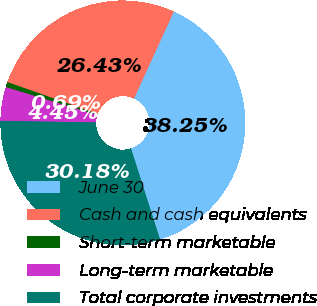Convert chart. <chart><loc_0><loc_0><loc_500><loc_500><pie_chart><fcel>June 30<fcel>Cash and cash equivalents<fcel>Short-term marketable<fcel>Long-term marketable<fcel>Total corporate investments<nl><fcel>38.25%<fcel>26.43%<fcel>0.69%<fcel>4.45%<fcel>30.18%<nl></chart> 